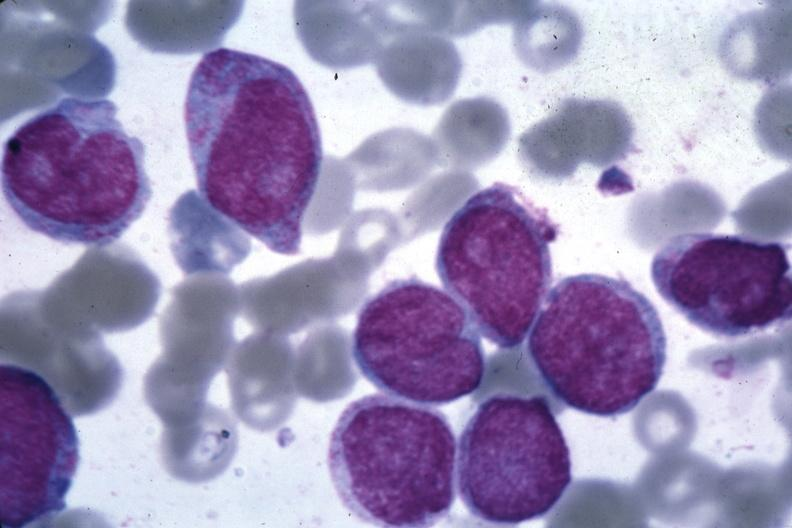does this image show oil wrights good photo blast cells?
Answer the question using a single word or phrase. Yes 